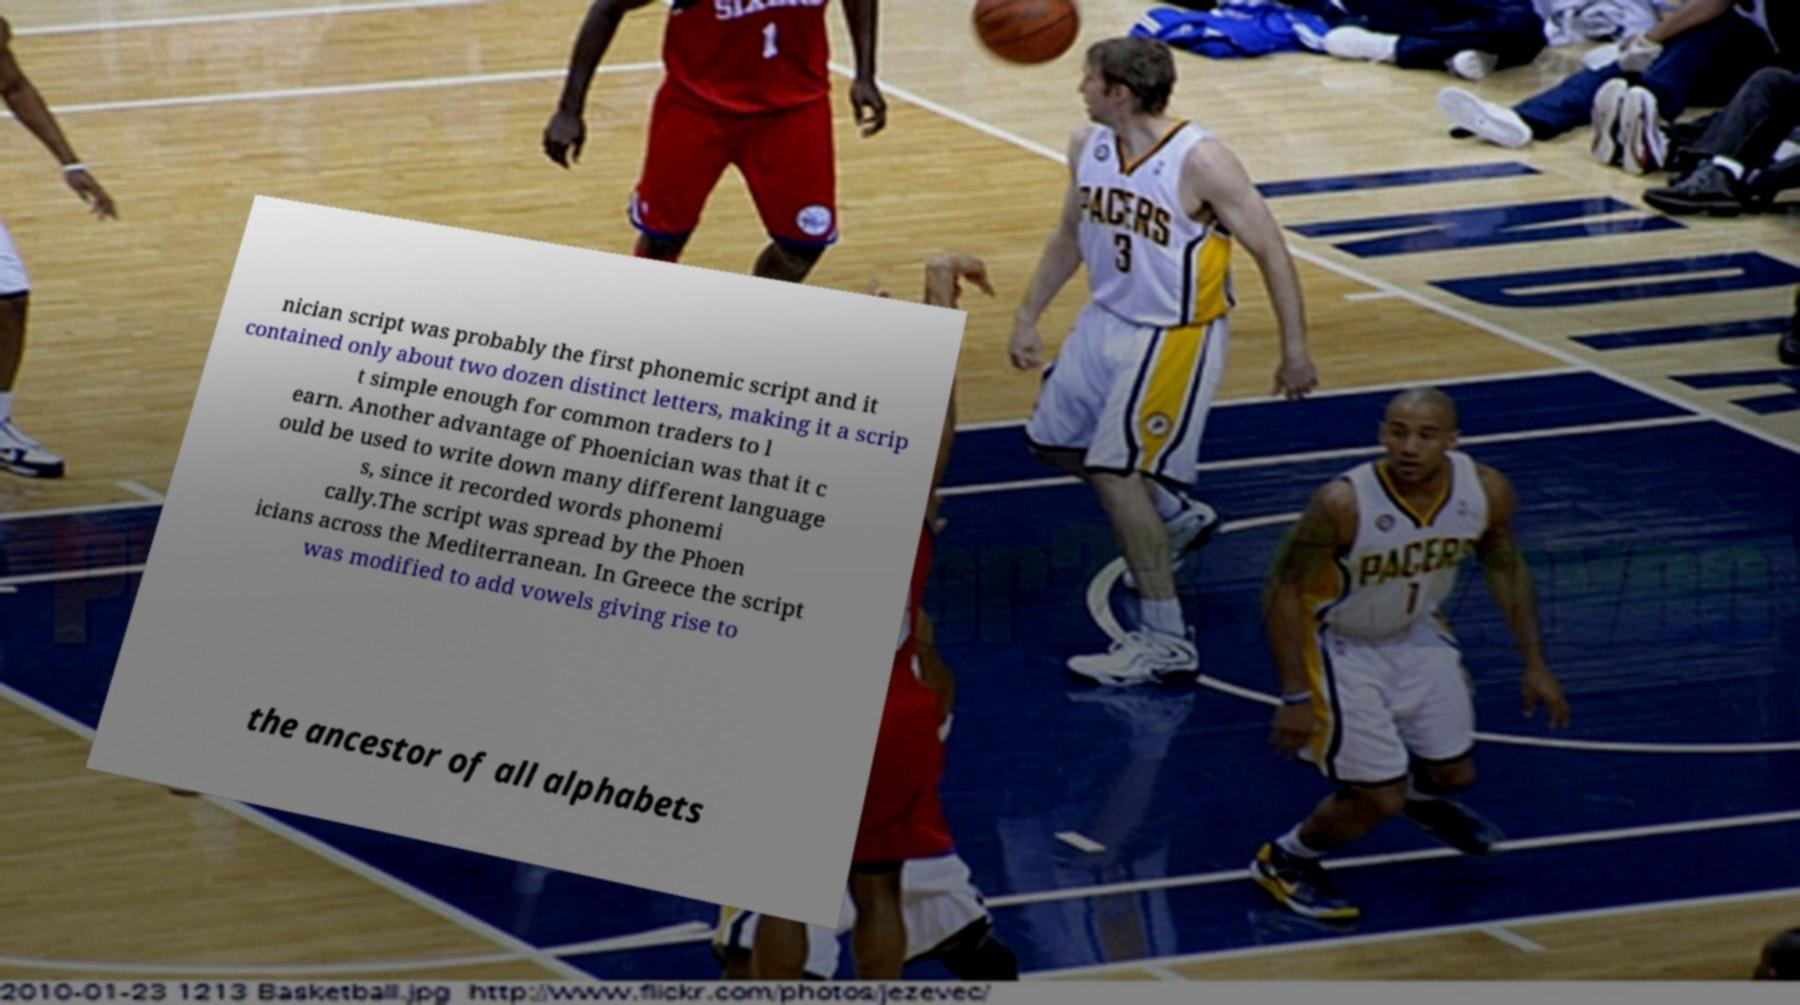Can you accurately transcribe the text from the provided image for me? nician script was probably the first phonemic script and it contained only about two dozen distinct letters, making it a scrip t simple enough for common traders to l earn. Another advantage of Phoenician was that it c ould be used to write down many different language s, since it recorded words phonemi cally.The script was spread by the Phoen icians across the Mediterranean. In Greece the script was modified to add vowels giving rise to the ancestor of all alphabets 